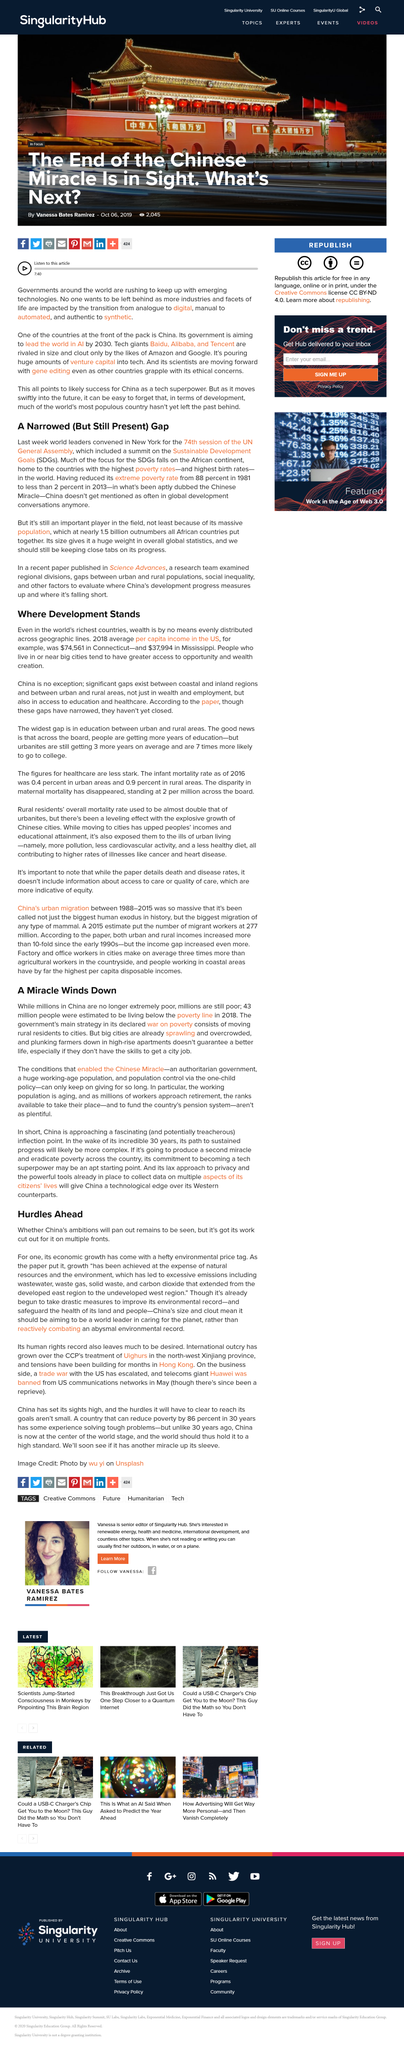Mention a couple of crucial points in this snapshot. In 2018, the per capita income in Connecticut, a state in the United States, was $74,561. The first name of the author of the article is Vanessa. China took drastic measures to improve its environmental record in order to safeguard the health of its lands and people. The pollution extended from the developed east to the undeveloped region, with a range of pollution sources that have been harmful to the environment. The Chinese Miracle is not a war on anything, but rather a war on poverty, as it aims to eradicate poverty and improve the standard of living for all Chinese citizens. 